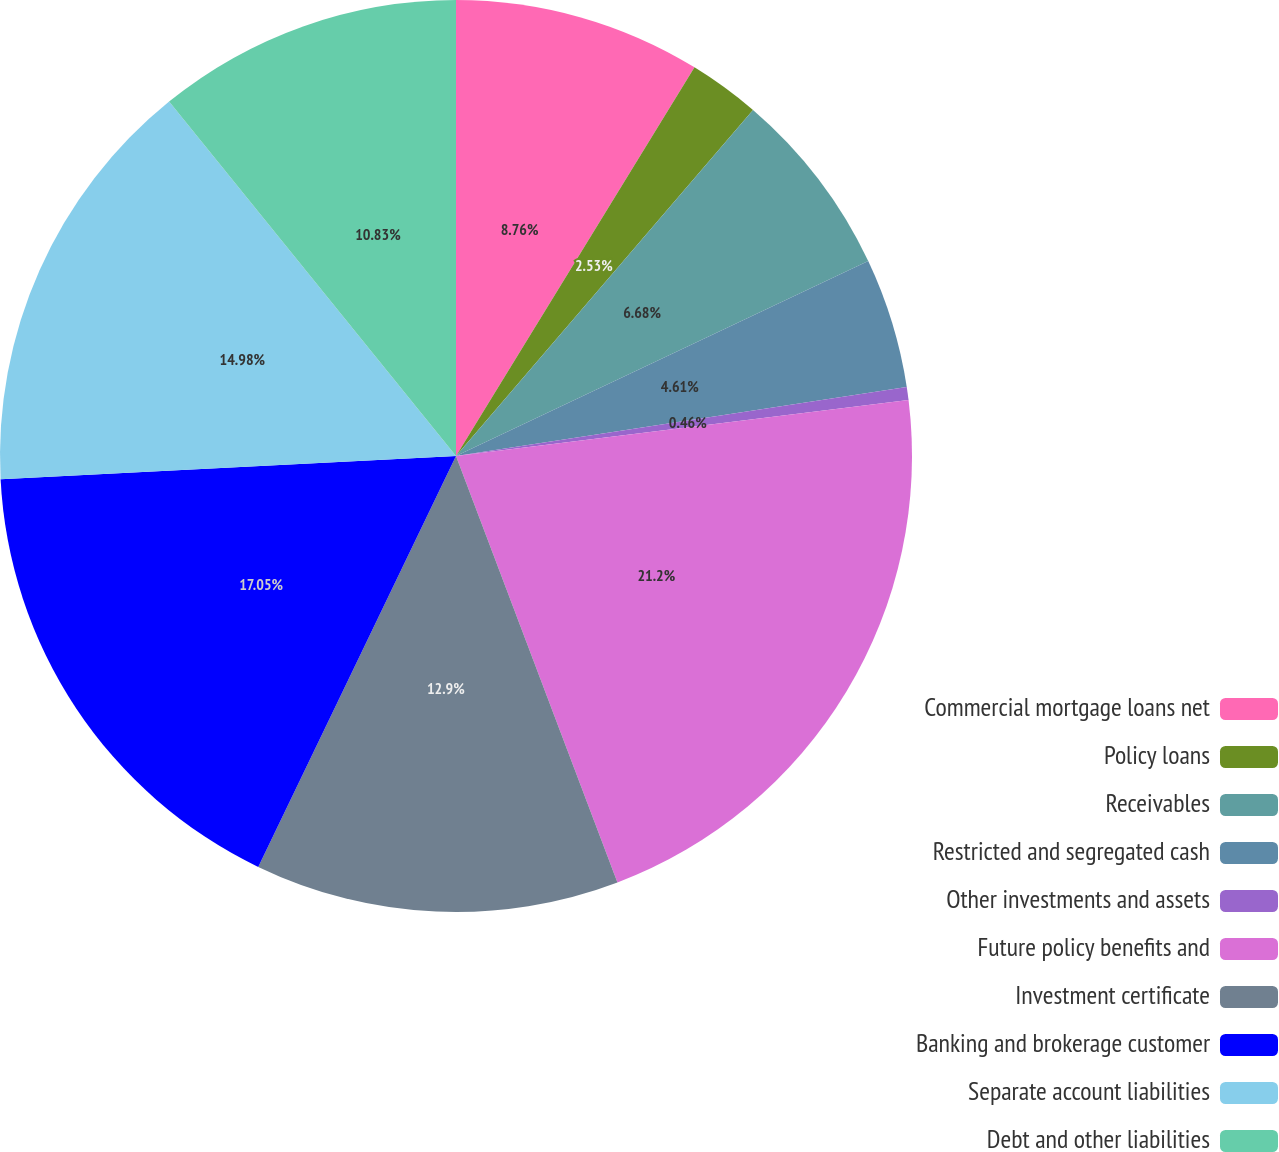Convert chart. <chart><loc_0><loc_0><loc_500><loc_500><pie_chart><fcel>Commercial mortgage loans net<fcel>Policy loans<fcel>Receivables<fcel>Restricted and segregated cash<fcel>Other investments and assets<fcel>Future policy benefits and<fcel>Investment certificate<fcel>Banking and brokerage customer<fcel>Separate account liabilities<fcel>Debt and other liabilities<nl><fcel>8.76%<fcel>2.53%<fcel>6.68%<fcel>4.61%<fcel>0.46%<fcel>21.2%<fcel>12.9%<fcel>17.05%<fcel>14.98%<fcel>10.83%<nl></chart> 